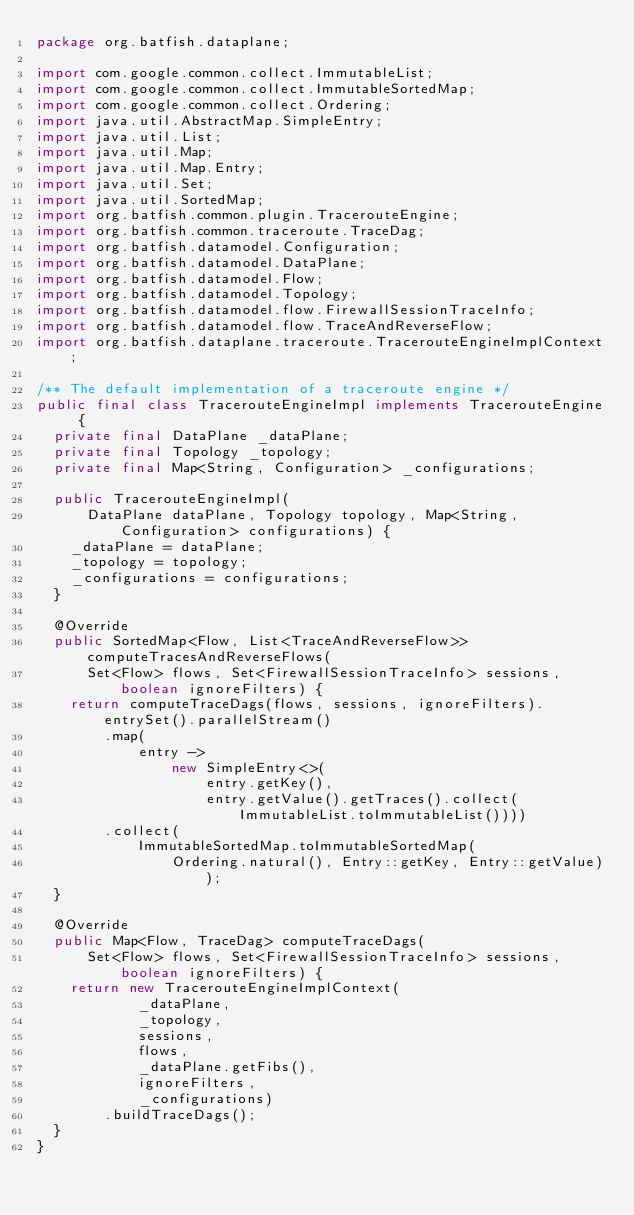Convert code to text. <code><loc_0><loc_0><loc_500><loc_500><_Java_>package org.batfish.dataplane;

import com.google.common.collect.ImmutableList;
import com.google.common.collect.ImmutableSortedMap;
import com.google.common.collect.Ordering;
import java.util.AbstractMap.SimpleEntry;
import java.util.List;
import java.util.Map;
import java.util.Map.Entry;
import java.util.Set;
import java.util.SortedMap;
import org.batfish.common.plugin.TracerouteEngine;
import org.batfish.common.traceroute.TraceDag;
import org.batfish.datamodel.Configuration;
import org.batfish.datamodel.DataPlane;
import org.batfish.datamodel.Flow;
import org.batfish.datamodel.Topology;
import org.batfish.datamodel.flow.FirewallSessionTraceInfo;
import org.batfish.datamodel.flow.TraceAndReverseFlow;
import org.batfish.dataplane.traceroute.TracerouteEngineImplContext;

/** The default implementation of a traceroute engine */
public final class TracerouteEngineImpl implements TracerouteEngine {
  private final DataPlane _dataPlane;
  private final Topology _topology;
  private final Map<String, Configuration> _configurations;

  public TracerouteEngineImpl(
      DataPlane dataPlane, Topology topology, Map<String, Configuration> configurations) {
    _dataPlane = dataPlane;
    _topology = topology;
    _configurations = configurations;
  }

  @Override
  public SortedMap<Flow, List<TraceAndReverseFlow>> computeTracesAndReverseFlows(
      Set<Flow> flows, Set<FirewallSessionTraceInfo> sessions, boolean ignoreFilters) {
    return computeTraceDags(flows, sessions, ignoreFilters).entrySet().parallelStream()
        .map(
            entry ->
                new SimpleEntry<>(
                    entry.getKey(),
                    entry.getValue().getTraces().collect(ImmutableList.toImmutableList())))
        .collect(
            ImmutableSortedMap.toImmutableSortedMap(
                Ordering.natural(), Entry::getKey, Entry::getValue));
  }

  @Override
  public Map<Flow, TraceDag> computeTraceDags(
      Set<Flow> flows, Set<FirewallSessionTraceInfo> sessions, boolean ignoreFilters) {
    return new TracerouteEngineImplContext(
            _dataPlane,
            _topology,
            sessions,
            flows,
            _dataPlane.getFibs(),
            ignoreFilters,
            _configurations)
        .buildTraceDags();
  }
}
</code> 